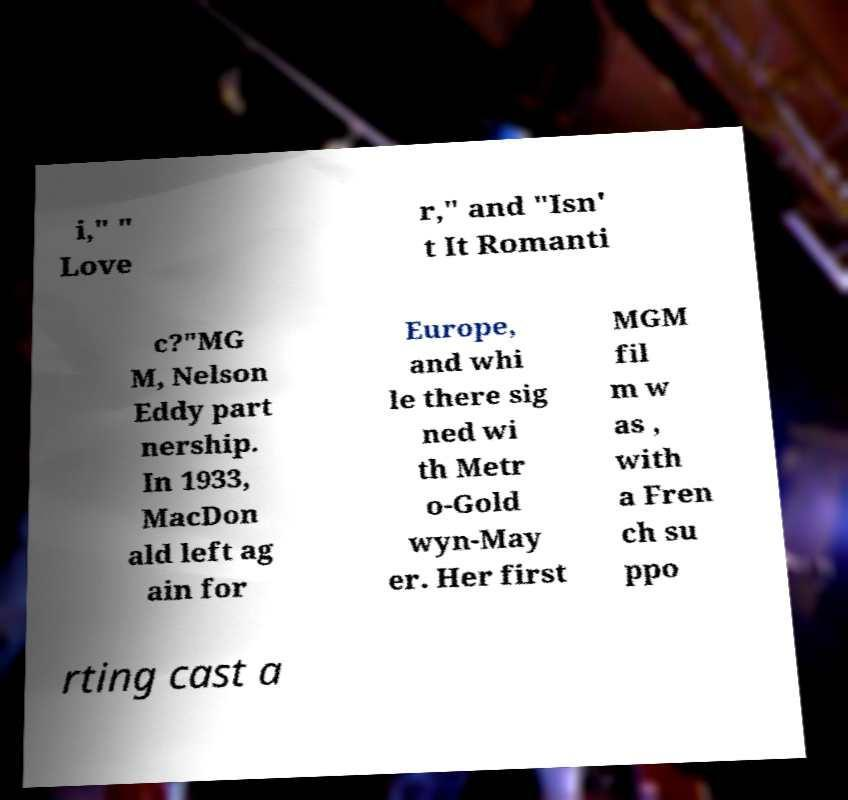For documentation purposes, I need the text within this image transcribed. Could you provide that? i," " Love r," and "Isn' t It Romanti c?"MG M, Nelson Eddy part nership. In 1933, MacDon ald left ag ain for Europe, and whi le there sig ned wi th Metr o-Gold wyn-May er. Her first MGM fil m w as , with a Fren ch su ppo rting cast a 